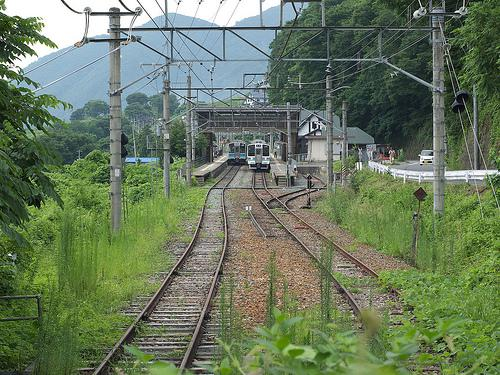Question: how many trains are fully visible here?
Choices:
A. Three.
B. Four.
C. One.
D. Two.
Answer with the letter. Answer: D Question: why are there wires above the track?
Choices:
A. To move the train.
B. To power the train.
C. For electricity.
D. Because the train is electric.
Answer with the letter. Answer: D Question: where is the embankment?
Choices:
A. Between the train tracks and the road.
B. By the road.
C. By the cemetery.
D. Near my house.
Answer with the letter. Answer: A 